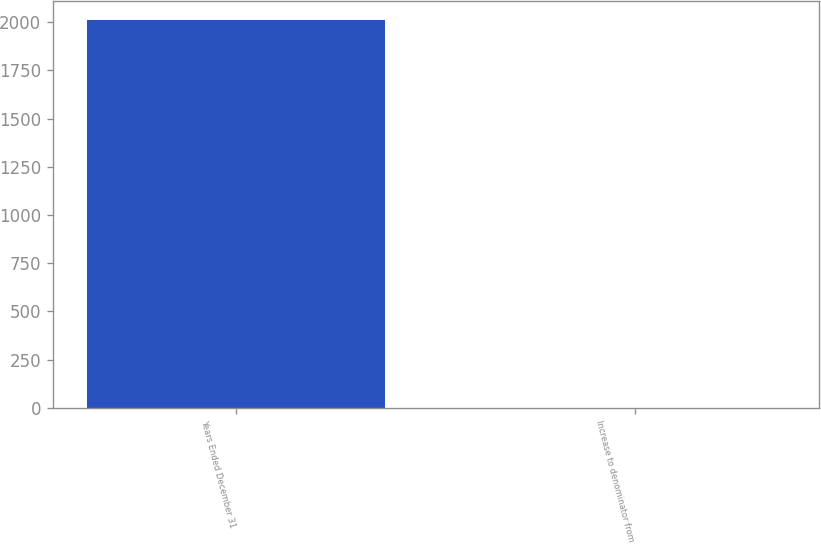Convert chart to OTSL. <chart><loc_0><loc_0><loc_500><loc_500><bar_chart><fcel>Years Ended December 31<fcel>Increase to denominator from<nl><fcel>2011<fcel>0.7<nl></chart> 